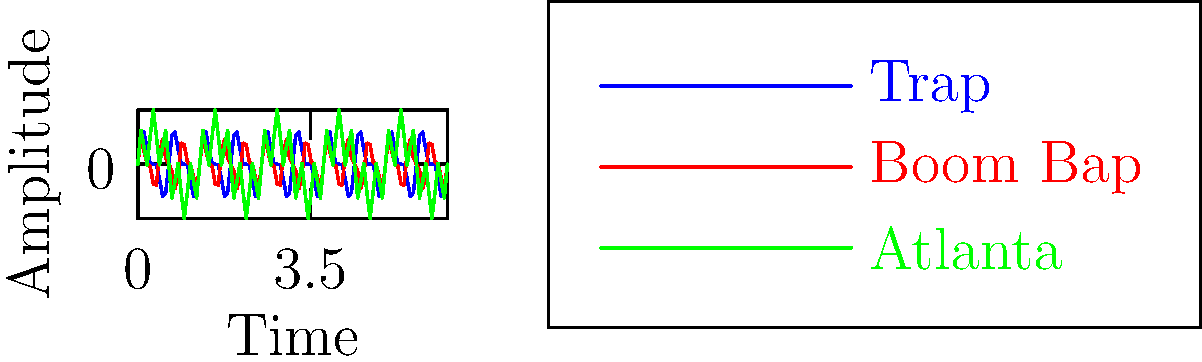As an emerging hip-hop artist, you're exploring different sub-genres and their sound characteristics. The graph above shows the waveform patterns of three popular hip-hop styles: Trap, Boom Bap, and Atlanta. Which style is represented by the blue line, and what key feature of its waveform sets it apart from the others? To answer this question, let's analyze the waveforms step-by-step:

1. Identify the blue line: The legend indicates that the blue line represents the Trap style.

2. Observe the characteristics of the blue line:
   - It has a complex waveform with rapid oscillations.
   - The pattern shows a combination of high and low frequencies.

3. Compare the blue line (Trap) to the other waveforms:
   - Red line (Boom Bap): Has a more uniform, medium-frequency pattern.
   - Green line (Atlanta): Shows wider, lower-frequency waves with some high-frequency components.

4. Key feature of Trap waveform:
   - The most distinctive feature is its high-frequency content, represented by the rapid, tight oscillations in the waveform.

5. Significance in Trap music:
   - These rapid oscillations correspond to the fast, intricate hi-hat patterns and snare rolls characteristic of Trap music.
   - The combination of high and low frequencies represents the contrast between deep bass and crisp, rapid percussion typical in Trap productions.

Therefore, the blue line represents Trap, and its key distinguishing feature is the presence of high-frequency, rapid oscillations in the waveform, reflecting the style's signature hi-hat and percussion patterns.
Answer: Trap; high-frequency, rapid oscillations 